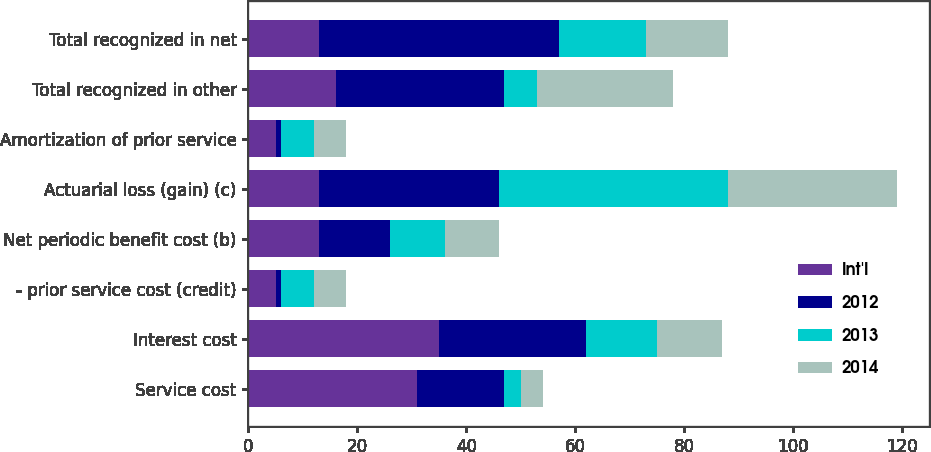Convert chart. <chart><loc_0><loc_0><loc_500><loc_500><stacked_bar_chart><ecel><fcel>Service cost<fcel>Interest cost<fcel>- prior service cost (credit)<fcel>Net periodic benefit cost (b)<fcel>Actuarial loss (gain) (c)<fcel>Amortization of prior service<fcel>Total recognized in other<fcel>Total recognized in net<nl><fcel>Int'l<fcel>31<fcel>35<fcel>5<fcel>13<fcel>13<fcel>5<fcel>16<fcel>13<nl><fcel>2012<fcel>16<fcel>27<fcel>1<fcel>13<fcel>33<fcel>1<fcel>31<fcel>44<nl><fcel>2013<fcel>3<fcel>13<fcel>6<fcel>10<fcel>42<fcel>6<fcel>6<fcel>16<nl><fcel>2014<fcel>4<fcel>12<fcel>6<fcel>10<fcel>31<fcel>6<fcel>25<fcel>15<nl></chart> 